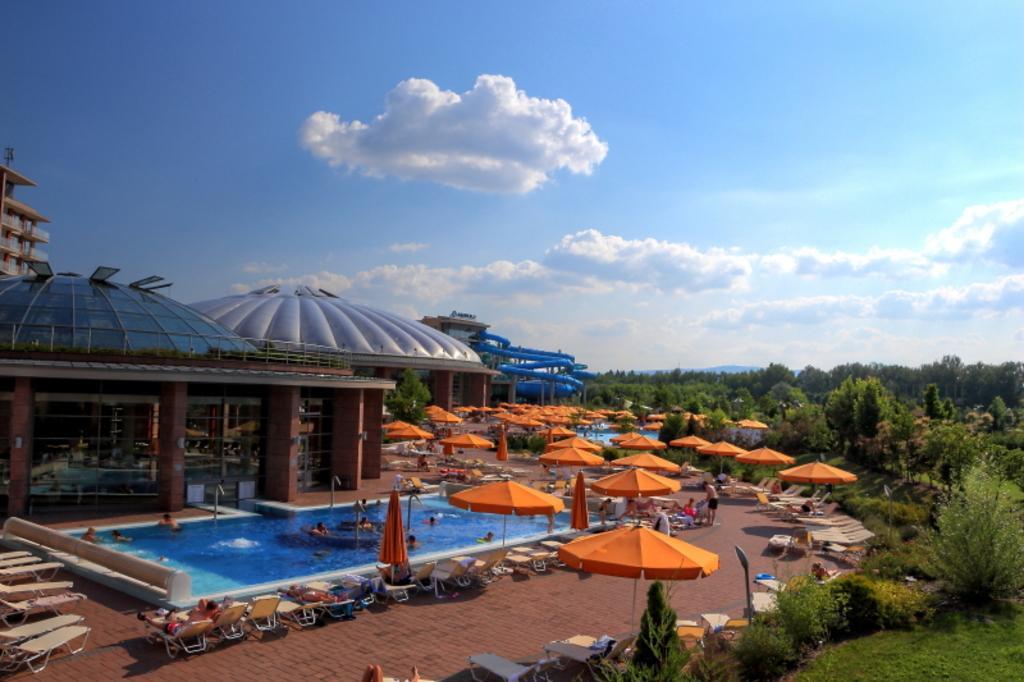Can you describe this image briefly? In this picture I can see buildings, few umbrellas, chairs and I can see few people in the swimming pool and few people on the chairs and I can see a slider, few trees, plants and a blue cloudy sky. 